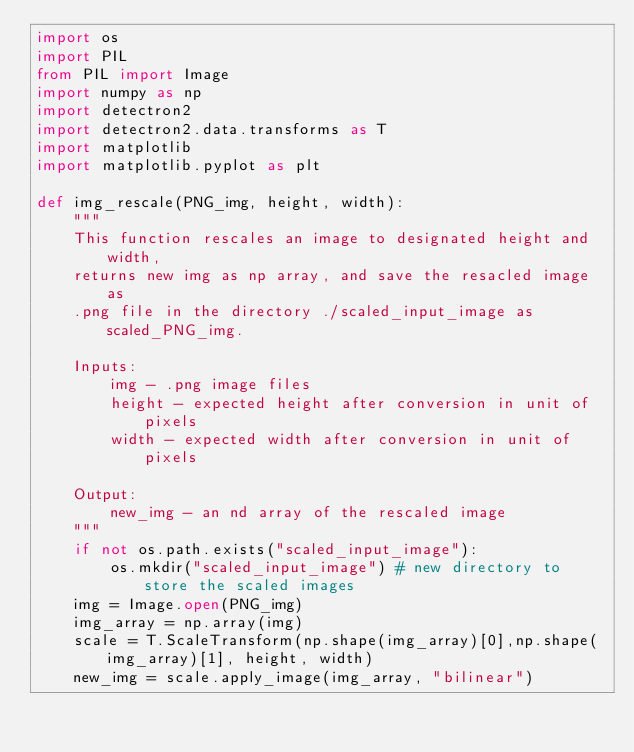<code> <loc_0><loc_0><loc_500><loc_500><_Python_>import os
import PIL
from PIL import Image
import numpy as np
import detectron2
import detectron2.data.transforms as T
import matplotlib
import matplotlib.pyplot as plt

def img_rescale(PNG_img, height, width):
    """
    This function rescales an image to designated height and width,
    returns new img as np array, and save the resacled image as
    .png file in the directory ./scaled_input_image as scaled_PNG_img.
    
    Inputs:
        img - .png image files
        height - expected height after conversion in unit of pixels
        width - expected width after conversion in unit of pixels
    
    Output:
        new_img - an nd array of the rescaled image 
    """
    if not os.path.exists("scaled_input_image"):
        os.mkdir("scaled_input_image") # new directory to store the scaled images
    img = Image.open(PNG_img) 
    img_array = np.array(img)
    scale = T.ScaleTransform(np.shape(img_array)[0],np.shape(img_array)[1], height, width)
    new_img = scale.apply_image(img_array, "bilinear")</code> 